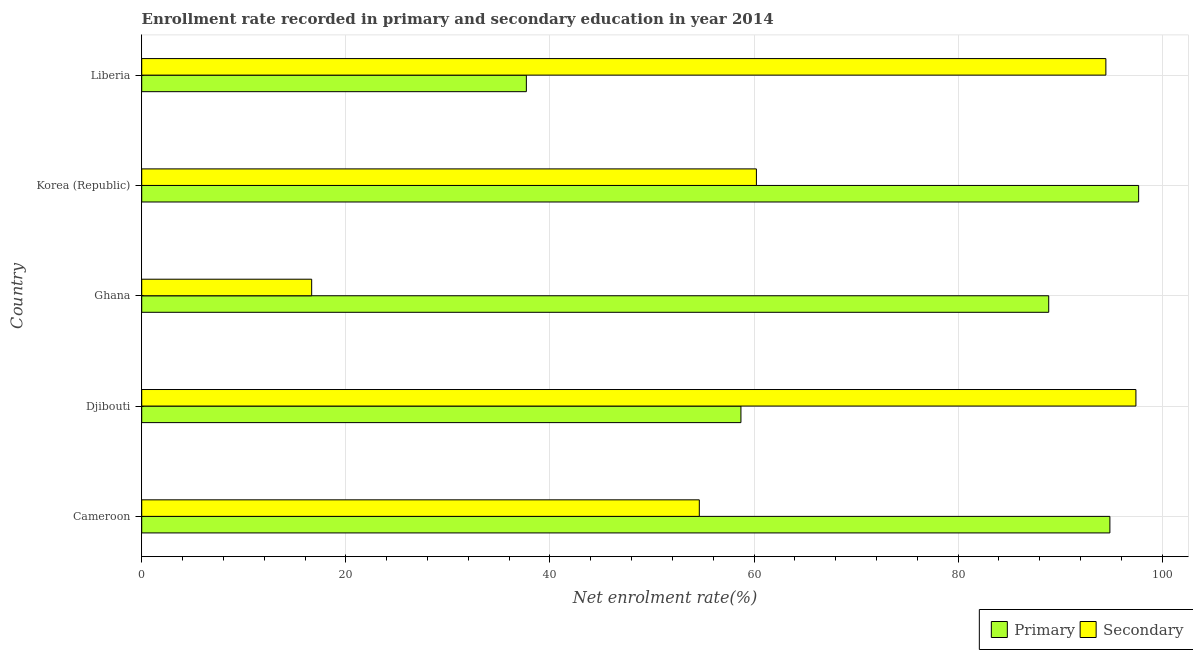How many different coloured bars are there?
Offer a very short reply. 2. How many groups of bars are there?
Your answer should be very brief. 5. What is the enrollment rate in primary education in Cameroon?
Ensure brevity in your answer.  94.87. Across all countries, what is the maximum enrollment rate in primary education?
Your response must be concise. 97.69. Across all countries, what is the minimum enrollment rate in primary education?
Keep it short and to the point. 37.69. In which country was the enrollment rate in primary education maximum?
Provide a succinct answer. Korea (Republic). In which country was the enrollment rate in primary education minimum?
Provide a short and direct response. Liberia. What is the total enrollment rate in primary education in the graph?
Provide a succinct answer. 377.84. What is the difference between the enrollment rate in primary education in Djibouti and that in Korea (Republic)?
Ensure brevity in your answer.  -38.97. What is the difference between the enrollment rate in primary education in Ghana and the enrollment rate in secondary education in Djibouti?
Provide a short and direct response. -8.54. What is the average enrollment rate in secondary education per country?
Give a very brief answer. 64.68. What is the difference between the enrollment rate in primary education and enrollment rate in secondary education in Djibouti?
Ensure brevity in your answer.  -38.7. In how many countries, is the enrollment rate in primary education greater than 56 %?
Provide a succinct answer. 4. What is the ratio of the enrollment rate in secondary education in Korea (Republic) to that in Liberia?
Keep it short and to the point. 0.64. Is the difference between the enrollment rate in secondary education in Djibouti and Ghana greater than the difference between the enrollment rate in primary education in Djibouti and Ghana?
Keep it short and to the point. Yes. What is the difference between the highest and the second highest enrollment rate in secondary education?
Ensure brevity in your answer.  2.94. What does the 2nd bar from the top in Cameroon represents?
Give a very brief answer. Primary. What does the 2nd bar from the bottom in Korea (Republic) represents?
Make the answer very short. Secondary. How many bars are there?
Provide a succinct answer. 10. Are the values on the major ticks of X-axis written in scientific E-notation?
Provide a short and direct response. No. Where does the legend appear in the graph?
Your response must be concise. Bottom right. How many legend labels are there?
Offer a terse response. 2. What is the title of the graph?
Keep it short and to the point. Enrollment rate recorded in primary and secondary education in year 2014. What is the label or title of the X-axis?
Your response must be concise. Net enrolment rate(%). What is the Net enrolment rate(%) in Primary in Cameroon?
Your answer should be compact. 94.87. What is the Net enrolment rate(%) in Secondary in Cameroon?
Ensure brevity in your answer.  54.64. What is the Net enrolment rate(%) in Primary in Djibouti?
Your response must be concise. 58.72. What is the Net enrolment rate(%) in Secondary in Djibouti?
Keep it short and to the point. 97.42. What is the Net enrolment rate(%) of Primary in Ghana?
Keep it short and to the point. 88.88. What is the Net enrolment rate(%) in Secondary in Ghana?
Keep it short and to the point. 16.65. What is the Net enrolment rate(%) in Primary in Korea (Republic)?
Provide a short and direct response. 97.69. What is the Net enrolment rate(%) in Secondary in Korea (Republic)?
Give a very brief answer. 60.23. What is the Net enrolment rate(%) in Primary in Liberia?
Provide a succinct answer. 37.69. What is the Net enrolment rate(%) in Secondary in Liberia?
Give a very brief answer. 94.48. Across all countries, what is the maximum Net enrolment rate(%) in Primary?
Make the answer very short. 97.69. Across all countries, what is the maximum Net enrolment rate(%) of Secondary?
Offer a very short reply. 97.42. Across all countries, what is the minimum Net enrolment rate(%) in Primary?
Provide a succinct answer. 37.69. Across all countries, what is the minimum Net enrolment rate(%) of Secondary?
Offer a very short reply. 16.65. What is the total Net enrolment rate(%) in Primary in the graph?
Make the answer very short. 377.84. What is the total Net enrolment rate(%) in Secondary in the graph?
Offer a very short reply. 323.42. What is the difference between the Net enrolment rate(%) of Primary in Cameroon and that in Djibouti?
Your answer should be compact. 36.15. What is the difference between the Net enrolment rate(%) of Secondary in Cameroon and that in Djibouti?
Provide a succinct answer. -42.78. What is the difference between the Net enrolment rate(%) in Primary in Cameroon and that in Ghana?
Your answer should be compact. 5.99. What is the difference between the Net enrolment rate(%) in Secondary in Cameroon and that in Ghana?
Offer a very short reply. 37.98. What is the difference between the Net enrolment rate(%) of Primary in Cameroon and that in Korea (Republic)?
Offer a very short reply. -2.82. What is the difference between the Net enrolment rate(%) in Secondary in Cameroon and that in Korea (Republic)?
Your answer should be compact. -5.59. What is the difference between the Net enrolment rate(%) of Primary in Cameroon and that in Liberia?
Offer a very short reply. 57.18. What is the difference between the Net enrolment rate(%) in Secondary in Cameroon and that in Liberia?
Offer a terse response. -39.84. What is the difference between the Net enrolment rate(%) of Primary in Djibouti and that in Ghana?
Your answer should be compact. -30.16. What is the difference between the Net enrolment rate(%) in Secondary in Djibouti and that in Ghana?
Give a very brief answer. 80.77. What is the difference between the Net enrolment rate(%) in Primary in Djibouti and that in Korea (Republic)?
Your answer should be compact. -38.97. What is the difference between the Net enrolment rate(%) of Secondary in Djibouti and that in Korea (Republic)?
Your response must be concise. 37.19. What is the difference between the Net enrolment rate(%) of Primary in Djibouti and that in Liberia?
Make the answer very short. 21.03. What is the difference between the Net enrolment rate(%) in Secondary in Djibouti and that in Liberia?
Your response must be concise. 2.95. What is the difference between the Net enrolment rate(%) of Primary in Ghana and that in Korea (Republic)?
Offer a very short reply. -8.81. What is the difference between the Net enrolment rate(%) of Secondary in Ghana and that in Korea (Republic)?
Offer a very short reply. -43.58. What is the difference between the Net enrolment rate(%) of Primary in Ghana and that in Liberia?
Provide a succinct answer. 51.19. What is the difference between the Net enrolment rate(%) of Secondary in Ghana and that in Liberia?
Provide a short and direct response. -77.82. What is the difference between the Net enrolment rate(%) of Primary in Korea (Republic) and that in Liberia?
Provide a succinct answer. 60. What is the difference between the Net enrolment rate(%) of Secondary in Korea (Republic) and that in Liberia?
Offer a very short reply. -34.24. What is the difference between the Net enrolment rate(%) of Primary in Cameroon and the Net enrolment rate(%) of Secondary in Djibouti?
Your response must be concise. -2.55. What is the difference between the Net enrolment rate(%) in Primary in Cameroon and the Net enrolment rate(%) in Secondary in Ghana?
Provide a short and direct response. 78.22. What is the difference between the Net enrolment rate(%) in Primary in Cameroon and the Net enrolment rate(%) in Secondary in Korea (Republic)?
Offer a very short reply. 34.64. What is the difference between the Net enrolment rate(%) of Primary in Cameroon and the Net enrolment rate(%) of Secondary in Liberia?
Provide a short and direct response. 0.39. What is the difference between the Net enrolment rate(%) of Primary in Djibouti and the Net enrolment rate(%) of Secondary in Ghana?
Keep it short and to the point. 42.06. What is the difference between the Net enrolment rate(%) in Primary in Djibouti and the Net enrolment rate(%) in Secondary in Korea (Republic)?
Give a very brief answer. -1.52. What is the difference between the Net enrolment rate(%) of Primary in Djibouti and the Net enrolment rate(%) of Secondary in Liberia?
Offer a terse response. -35.76. What is the difference between the Net enrolment rate(%) of Primary in Ghana and the Net enrolment rate(%) of Secondary in Korea (Republic)?
Provide a short and direct response. 28.64. What is the difference between the Net enrolment rate(%) in Primary in Ghana and the Net enrolment rate(%) in Secondary in Liberia?
Ensure brevity in your answer.  -5.6. What is the difference between the Net enrolment rate(%) of Primary in Korea (Republic) and the Net enrolment rate(%) of Secondary in Liberia?
Keep it short and to the point. 3.21. What is the average Net enrolment rate(%) in Primary per country?
Offer a terse response. 75.57. What is the average Net enrolment rate(%) in Secondary per country?
Offer a terse response. 64.68. What is the difference between the Net enrolment rate(%) of Primary and Net enrolment rate(%) of Secondary in Cameroon?
Make the answer very short. 40.23. What is the difference between the Net enrolment rate(%) of Primary and Net enrolment rate(%) of Secondary in Djibouti?
Your response must be concise. -38.7. What is the difference between the Net enrolment rate(%) of Primary and Net enrolment rate(%) of Secondary in Ghana?
Your answer should be compact. 72.22. What is the difference between the Net enrolment rate(%) in Primary and Net enrolment rate(%) in Secondary in Korea (Republic)?
Offer a terse response. 37.45. What is the difference between the Net enrolment rate(%) of Primary and Net enrolment rate(%) of Secondary in Liberia?
Offer a terse response. -56.79. What is the ratio of the Net enrolment rate(%) in Primary in Cameroon to that in Djibouti?
Your answer should be very brief. 1.62. What is the ratio of the Net enrolment rate(%) of Secondary in Cameroon to that in Djibouti?
Give a very brief answer. 0.56. What is the ratio of the Net enrolment rate(%) of Primary in Cameroon to that in Ghana?
Provide a succinct answer. 1.07. What is the ratio of the Net enrolment rate(%) of Secondary in Cameroon to that in Ghana?
Keep it short and to the point. 3.28. What is the ratio of the Net enrolment rate(%) of Primary in Cameroon to that in Korea (Republic)?
Your answer should be very brief. 0.97. What is the ratio of the Net enrolment rate(%) of Secondary in Cameroon to that in Korea (Republic)?
Your response must be concise. 0.91. What is the ratio of the Net enrolment rate(%) in Primary in Cameroon to that in Liberia?
Provide a succinct answer. 2.52. What is the ratio of the Net enrolment rate(%) in Secondary in Cameroon to that in Liberia?
Make the answer very short. 0.58. What is the ratio of the Net enrolment rate(%) of Primary in Djibouti to that in Ghana?
Your response must be concise. 0.66. What is the ratio of the Net enrolment rate(%) of Secondary in Djibouti to that in Ghana?
Ensure brevity in your answer.  5.85. What is the ratio of the Net enrolment rate(%) of Primary in Djibouti to that in Korea (Republic)?
Your answer should be compact. 0.6. What is the ratio of the Net enrolment rate(%) in Secondary in Djibouti to that in Korea (Republic)?
Keep it short and to the point. 1.62. What is the ratio of the Net enrolment rate(%) of Primary in Djibouti to that in Liberia?
Make the answer very short. 1.56. What is the ratio of the Net enrolment rate(%) in Secondary in Djibouti to that in Liberia?
Your answer should be very brief. 1.03. What is the ratio of the Net enrolment rate(%) of Primary in Ghana to that in Korea (Republic)?
Offer a terse response. 0.91. What is the ratio of the Net enrolment rate(%) in Secondary in Ghana to that in Korea (Republic)?
Your answer should be compact. 0.28. What is the ratio of the Net enrolment rate(%) in Primary in Ghana to that in Liberia?
Your response must be concise. 2.36. What is the ratio of the Net enrolment rate(%) of Secondary in Ghana to that in Liberia?
Provide a short and direct response. 0.18. What is the ratio of the Net enrolment rate(%) in Primary in Korea (Republic) to that in Liberia?
Offer a terse response. 2.59. What is the ratio of the Net enrolment rate(%) of Secondary in Korea (Republic) to that in Liberia?
Your response must be concise. 0.64. What is the difference between the highest and the second highest Net enrolment rate(%) of Primary?
Provide a succinct answer. 2.82. What is the difference between the highest and the second highest Net enrolment rate(%) of Secondary?
Offer a terse response. 2.95. What is the difference between the highest and the lowest Net enrolment rate(%) in Primary?
Ensure brevity in your answer.  60. What is the difference between the highest and the lowest Net enrolment rate(%) in Secondary?
Ensure brevity in your answer.  80.77. 